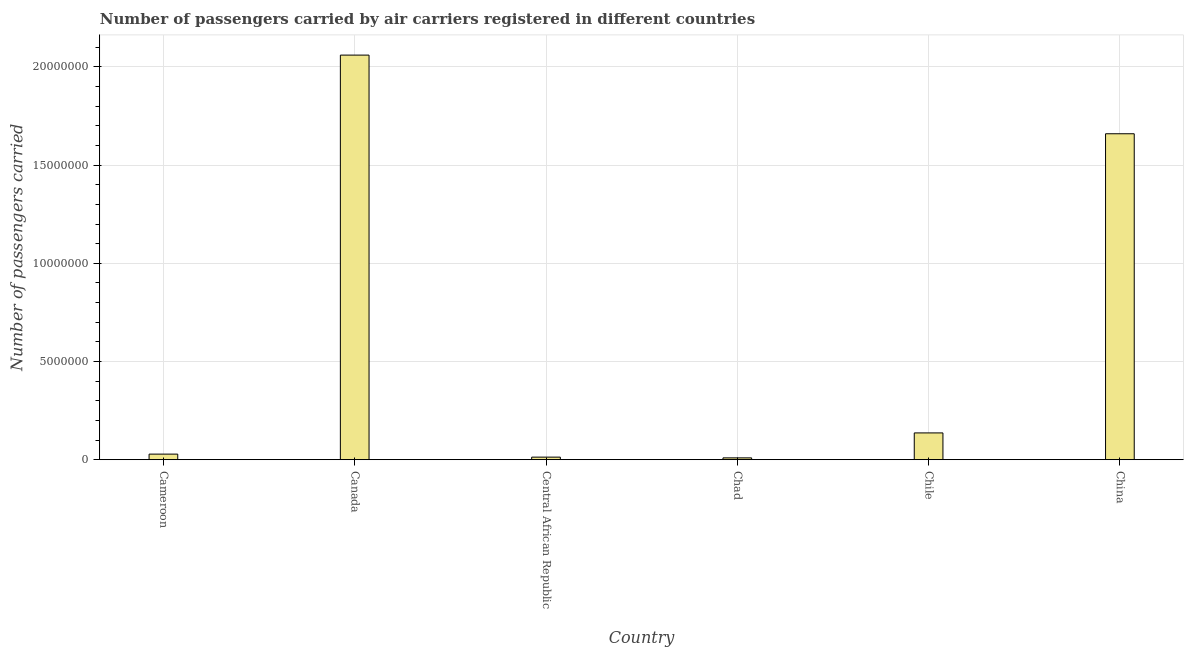Does the graph contain grids?
Provide a short and direct response. Yes. What is the title of the graph?
Your response must be concise. Number of passengers carried by air carriers registered in different countries. What is the label or title of the X-axis?
Provide a succinct answer. Country. What is the label or title of the Y-axis?
Keep it short and to the point. Number of passengers carried. What is the number of passengers carried in China?
Your response must be concise. 1.66e+07. Across all countries, what is the maximum number of passengers carried?
Your response must be concise. 2.06e+07. Across all countries, what is the minimum number of passengers carried?
Your answer should be very brief. 9.33e+04. In which country was the number of passengers carried minimum?
Your answer should be compact. Chad. What is the sum of the number of passengers carried?
Offer a terse response. 3.91e+07. What is the difference between the number of passengers carried in Canada and China?
Your answer should be compact. 4.01e+06. What is the average number of passengers carried per country?
Your response must be concise. 6.51e+06. What is the median number of passengers carried?
Your answer should be compact. 8.24e+05. What is the ratio of the number of passengers carried in Canada to that in Central African Republic?
Make the answer very short. 158.11. Is the number of passengers carried in Canada less than that in Chile?
Offer a terse response. No. Is the difference between the number of passengers carried in Cameroon and Central African Republic greater than the difference between any two countries?
Offer a terse response. No. What is the difference between the highest and the second highest number of passengers carried?
Your response must be concise. 4.01e+06. What is the difference between the highest and the lowest number of passengers carried?
Offer a terse response. 2.05e+07. How many countries are there in the graph?
Your answer should be compact. 6. Are the values on the major ticks of Y-axis written in scientific E-notation?
Ensure brevity in your answer.  No. What is the Number of passengers carried of Cameroon?
Your answer should be very brief. 2.84e+05. What is the Number of passengers carried in Canada?
Make the answer very short. 2.06e+07. What is the Number of passengers carried in Central African Republic?
Provide a succinct answer. 1.30e+05. What is the Number of passengers carried of Chad?
Your answer should be compact. 9.33e+04. What is the Number of passengers carried in Chile?
Your answer should be very brief. 1.36e+06. What is the Number of passengers carried in China?
Make the answer very short. 1.66e+07. What is the difference between the Number of passengers carried in Cameroon and Canada?
Ensure brevity in your answer.  -2.03e+07. What is the difference between the Number of passengers carried in Cameroon and Central African Republic?
Your response must be concise. 1.54e+05. What is the difference between the Number of passengers carried in Cameroon and Chad?
Keep it short and to the point. 1.91e+05. What is the difference between the Number of passengers carried in Cameroon and Chile?
Keep it short and to the point. -1.08e+06. What is the difference between the Number of passengers carried in Cameroon and China?
Your response must be concise. -1.63e+07. What is the difference between the Number of passengers carried in Canada and Central African Republic?
Provide a succinct answer. 2.05e+07. What is the difference between the Number of passengers carried in Canada and Chad?
Give a very brief answer. 2.05e+07. What is the difference between the Number of passengers carried in Canada and Chile?
Keep it short and to the point. 1.92e+07. What is the difference between the Number of passengers carried in Canada and China?
Offer a terse response. 4.01e+06. What is the difference between the Number of passengers carried in Central African Republic and Chad?
Your answer should be compact. 3.70e+04. What is the difference between the Number of passengers carried in Central African Republic and Chile?
Offer a very short reply. -1.23e+06. What is the difference between the Number of passengers carried in Central African Republic and China?
Offer a very short reply. -1.65e+07. What is the difference between the Number of passengers carried in Chad and Chile?
Offer a very short reply. -1.27e+06. What is the difference between the Number of passengers carried in Chad and China?
Your answer should be compact. -1.65e+07. What is the difference between the Number of passengers carried in Chile and China?
Your answer should be very brief. -1.52e+07. What is the ratio of the Number of passengers carried in Cameroon to that in Canada?
Keep it short and to the point. 0.01. What is the ratio of the Number of passengers carried in Cameroon to that in Central African Republic?
Keep it short and to the point. 2.18. What is the ratio of the Number of passengers carried in Cameroon to that in Chad?
Make the answer very short. 3.05. What is the ratio of the Number of passengers carried in Cameroon to that in Chile?
Your answer should be very brief. 0.21. What is the ratio of the Number of passengers carried in Cameroon to that in China?
Provide a succinct answer. 0.02. What is the ratio of the Number of passengers carried in Canada to that in Central African Republic?
Give a very brief answer. 158.11. What is the ratio of the Number of passengers carried in Canada to that in Chad?
Provide a succinct answer. 220.81. What is the ratio of the Number of passengers carried in Canada to that in Chile?
Provide a succinct answer. 15.11. What is the ratio of the Number of passengers carried in Canada to that in China?
Your response must be concise. 1.24. What is the ratio of the Number of passengers carried in Central African Republic to that in Chad?
Keep it short and to the point. 1.4. What is the ratio of the Number of passengers carried in Central African Republic to that in Chile?
Keep it short and to the point. 0.1. What is the ratio of the Number of passengers carried in Central African Republic to that in China?
Provide a short and direct response. 0.01. What is the ratio of the Number of passengers carried in Chad to that in Chile?
Offer a very short reply. 0.07. What is the ratio of the Number of passengers carried in Chad to that in China?
Offer a terse response. 0.01. What is the ratio of the Number of passengers carried in Chile to that in China?
Make the answer very short. 0.08. 